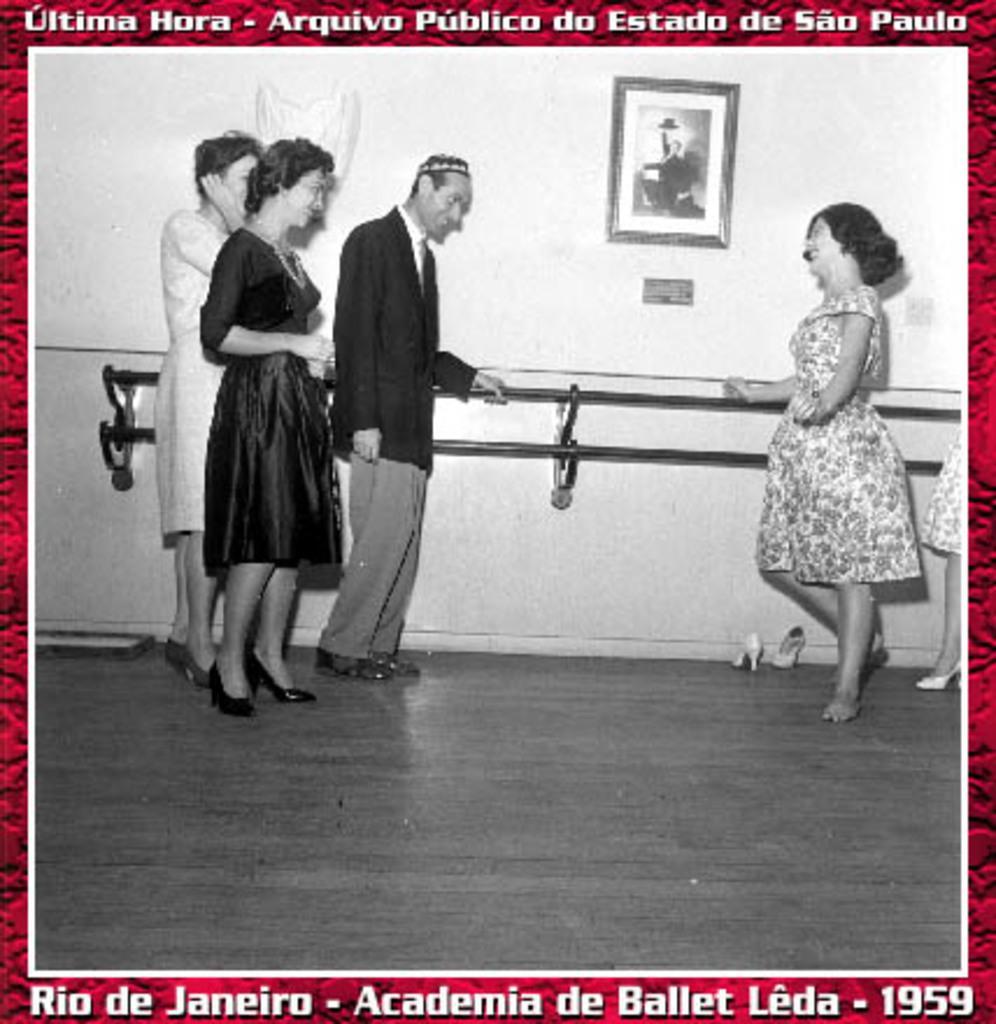In one or two sentences, can you explain what this image depicts? In this image we can see a black and white pic photograph on a poster and at the top and bottom we can see texts written on the poster and in the photo we can see three persons are standing on the left side on the floor and on the right side there are few persons standing on the floor and we can see foot wear at the wall and there is a frame and poles on the wall. 